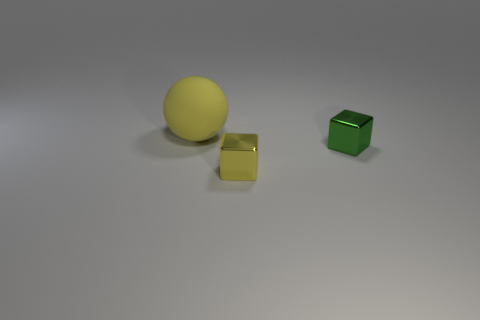Subtract all balls. How many objects are left? 2 Subtract 1 spheres. How many spheres are left? 0 Subtract all tiny yellow metal objects. Subtract all large yellow balls. How many objects are left? 1 Add 1 metal cubes. How many metal cubes are left? 3 Add 2 large yellow objects. How many large yellow objects exist? 3 Add 3 large brown matte cubes. How many objects exist? 6 Subtract 0 blue balls. How many objects are left? 3 Subtract all cyan spheres. Subtract all cyan blocks. How many spheres are left? 1 Subtract all purple spheres. How many yellow cubes are left? 1 